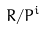Convert formula to latex. <formula><loc_0><loc_0><loc_500><loc_500>R / P ^ { i }</formula> 